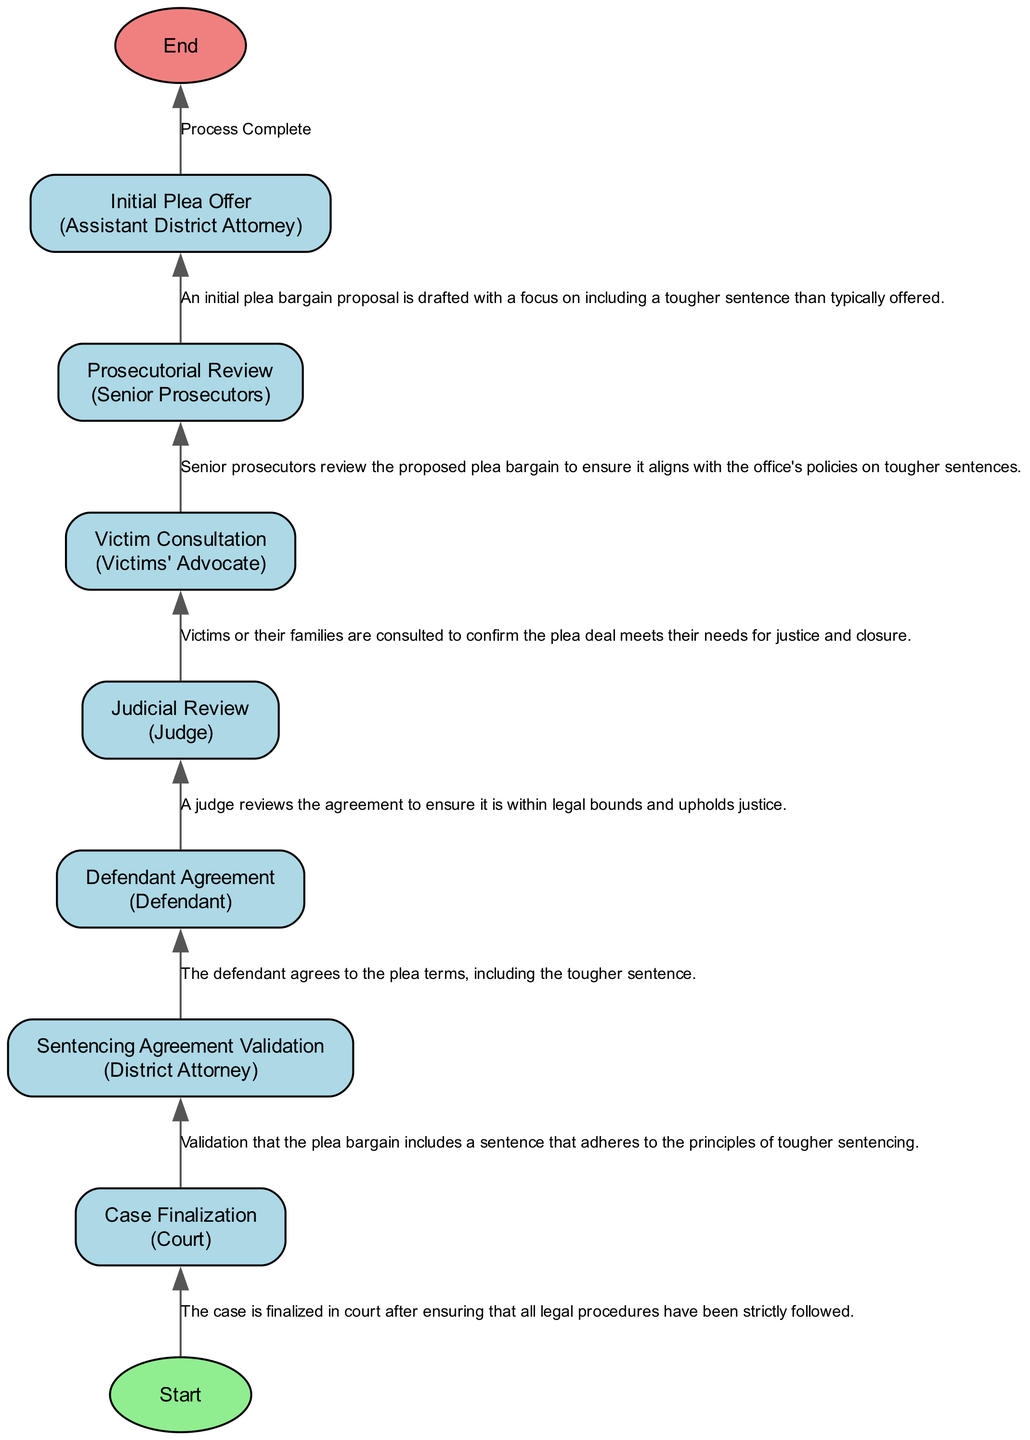What is the first step in the process? The first step in the process is the "Initial Plea Offer," which is indicated as the start of the flowchart and involves drafting a proposal for a plea bargain.
Answer: Initial Plea Offer Who is responsible for the "Sentencing Agreement Validation"? The "Sentencing Agreement Validation" is the responsibility of the "District Attorney," as stated in the diagram.
Answer: District Attorney How many steps are there in total? Counting all the steps in the Plea Bargain Approval Process, there are a total of 8 steps including the start and end nodes.
Answer: 8 What is the role of the "Victims' Advocate" in this process? The "Victims' Advocate" plays the role of consulting victims or their families to ensure the plea deal meets their needs, as described in the diagram.
Answer: Consult victims What step follows the "Prosecutorial Review"? The step that follows "Prosecutorial Review" is "Judicial Review," where the judge reviews the plea agreement for legality and justice.
Answer: Judicial Review Which step involves the defendant? The step that involves the defendant is "Defendant Agreement," where the defendant agrees to the terms of the plea deal, including the tougher sentence.
Answer: Defendant Agreement How does the flowchart indicate that the process has been completed? The flowchart indicates completion by showing an "End" node that is connected to the final step, marking the process as finished.
Answer: End What is the purpose of the "Victim Consultation"? The purpose of "Victim Consultation" is to confirm that the plea deal satisfies the victims' needs for justice and closure, as indicated in the description.
Answer: Confirm satisfaction What is the last step before the final review? The last step before the final review is "Judicial Review," where a judge assesses the plea agreement.
Answer: Judicial Review 